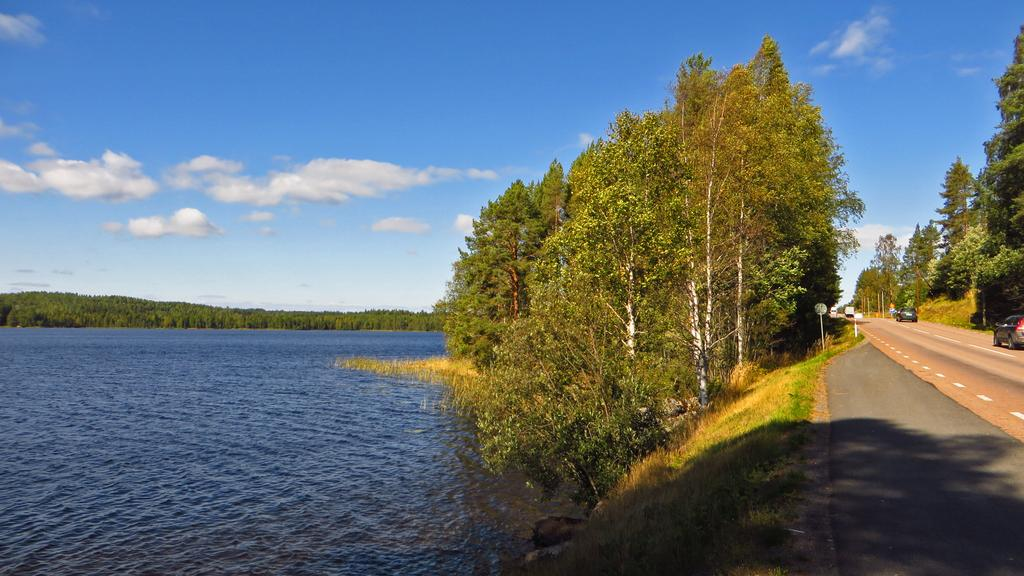What can be seen in the sky in the image? The sky with clouds is visible in the image. What type of vegetation is present in the image? There are trees in the image. What is the body of water visible in the image? There is water visible in the image. What type of ground surface is present in the image? Grass is present in the image. What type of signs can be seen in the image? Sign boards are in the image. What type of transportation is present on the road in the image? Motor vehicles are on the road in the image. How many sisters are playing with the ray in the image? There are no sisters or rays present in the image. What company is responsible for the sign boards in the image? The image does not provide information about the company responsible for the sign boards. 